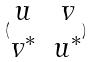<formula> <loc_0><loc_0><loc_500><loc_500>( \begin{matrix} u & v \\ v ^ { * } & u ^ { * } \end{matrix} )</formula> 